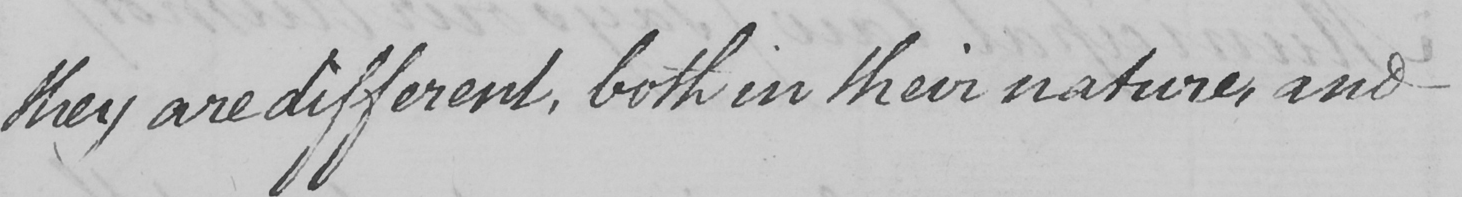What is written in this line of handwriting? they are different , both in their nature , and 